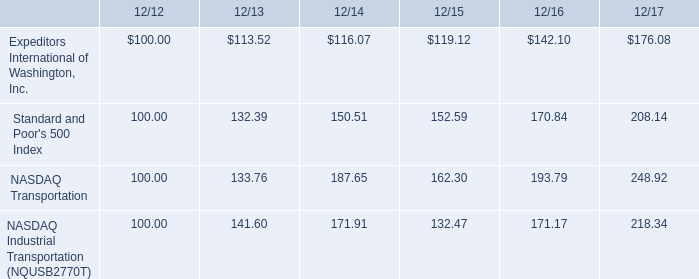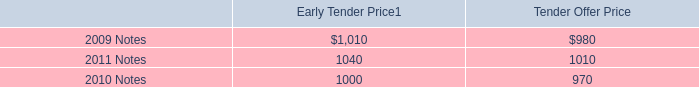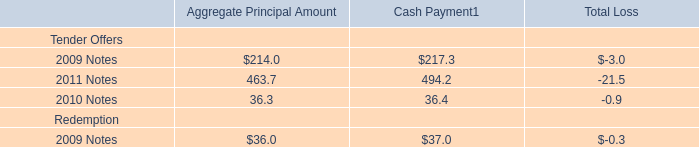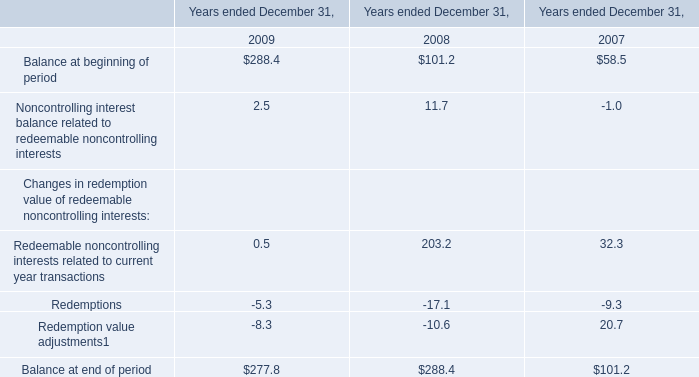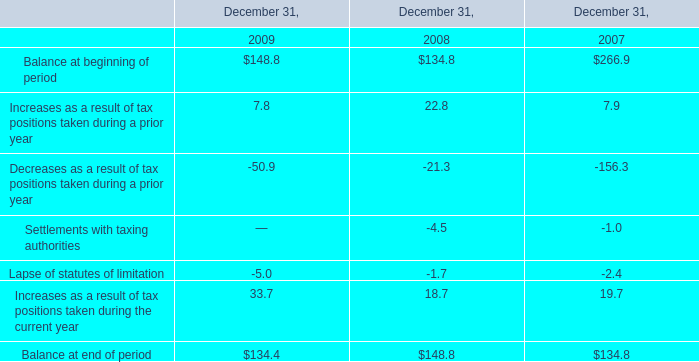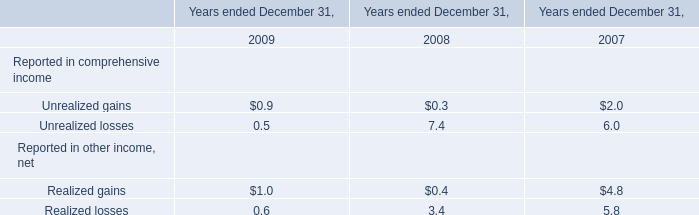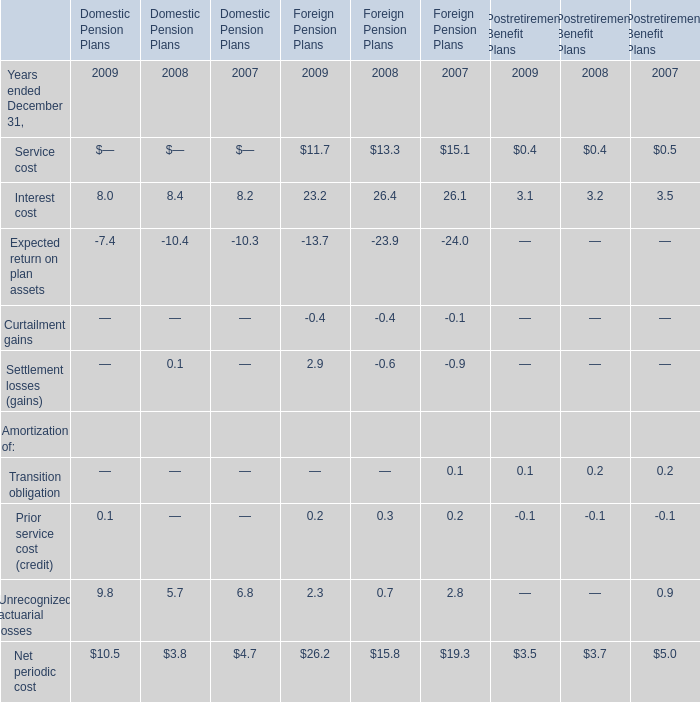What was the average value of the Service cost in the years where Interest cost positive is positive? 
Computations: ((((((11.7 + 13.3) + 15.1) + 0.4) + 0.4) + 0.5) / 3)
Answer: 13.8. 